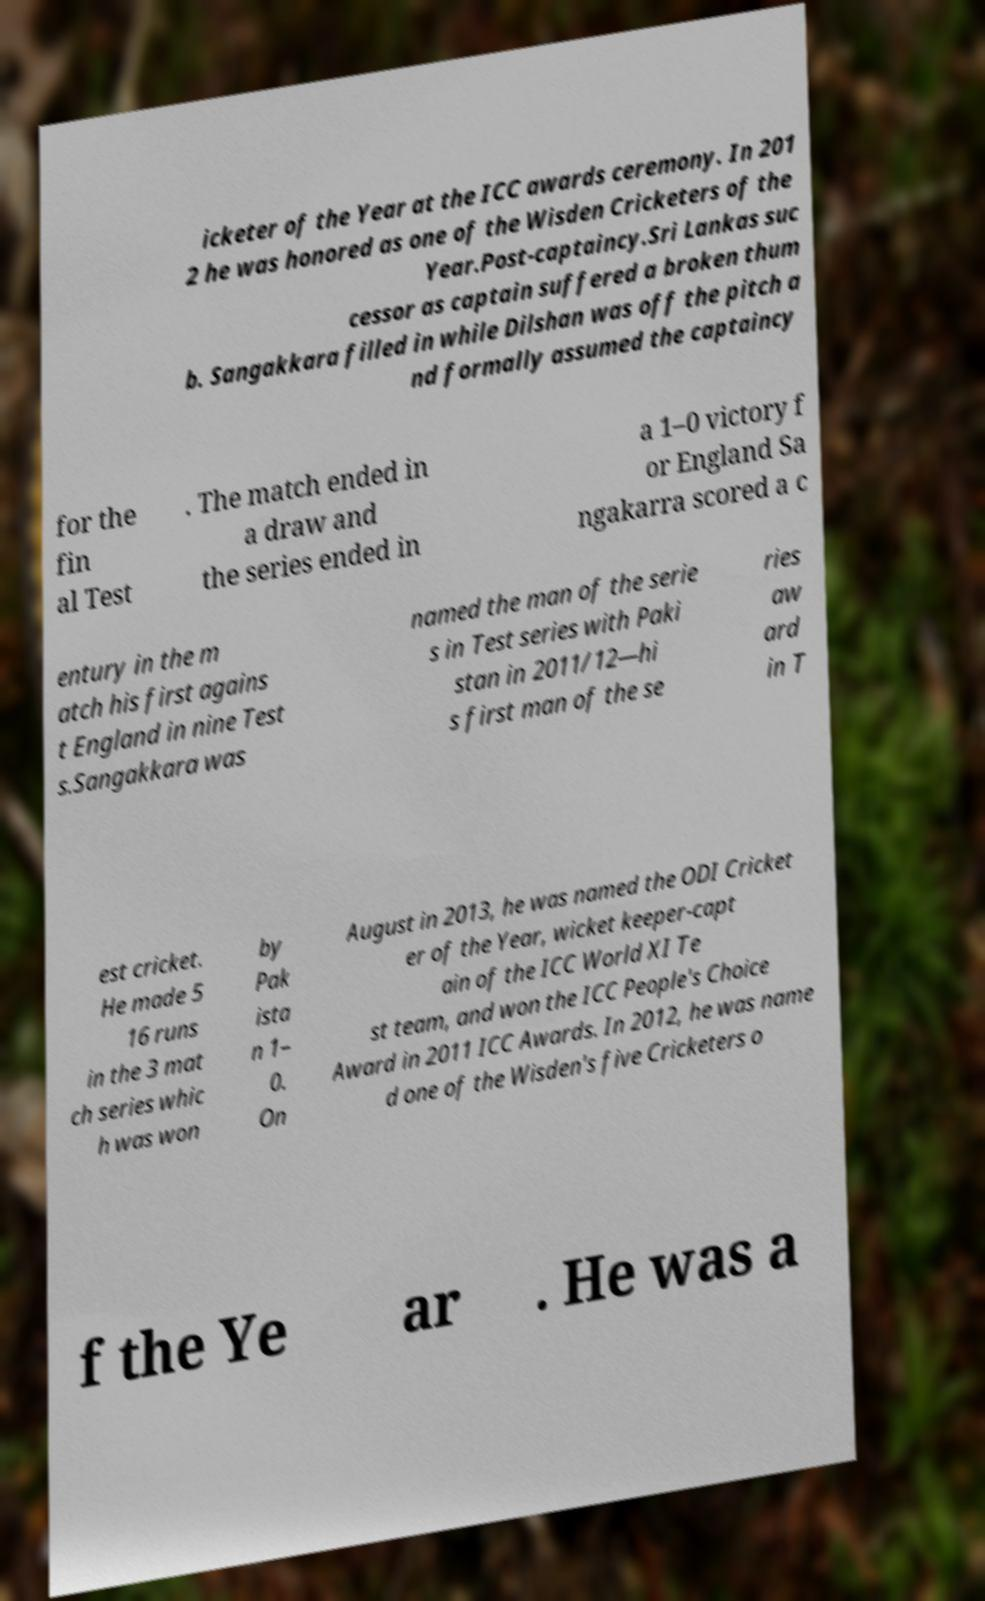Could you extract and type out the text from this image? icketer of the Year at the ICC awards ceremony. In 201 2 he was honored as one of the Wisden Cricketers of the Year.Post-captaincy.Sri Lankas suc cessor as captain suffered a broken thum b. Sangakkara filled in while Dilshan was off the pitch a nd formally assumed the captaincy for the fin al Test . The match ended in a draw and the series ended in a 1–0 victory f or England Sa ngakarra scored a c entury in the m atch his first agains t England in nine Test s.Sangakkara was named the man of the serie s in Test series with Paki stan in 2011/12—hi s first man of the se ries aw ard in T est cricket. He made 5 16 runs in the 3 mat ch series whic h was won by Pak ista n 1– 0. On August in 2013, he was named the ODI Cricket er of the Year, wicket keeper-capt ain of the ICC World XI Te st team, and won the ICC People's Choice Award in 2011 ICC Awards. In 2012, he was name d one of the Wisden's five Cricketers o f the Ye ar . He was a 